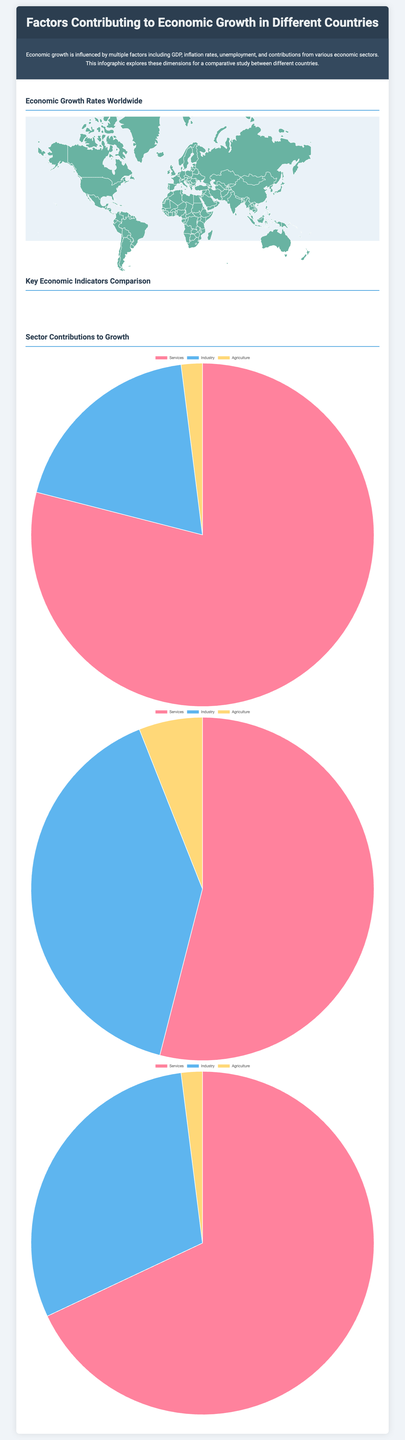what is the economic growth rate for China? The economic growth rate for China is depicted in the world map section, showing that it is 6.0.
Answer: 6.0 which country has the highest unemployment rate among those compared in the radar chart? The radar chart compares key economic indicators, indicating that the United States has the highest unemployment rate at 4.0.
Answer: 4.0 what percentage of the United States economy is contributed by the services sector? The pie chart for the United States illustrates that the services sector contributes 79.0% to the economy.
Answer: 79.0% which two countries have similar inflation rates according to the radar chart? The radar chart reveals that Germany and China both have similar inflation rates of 1.8 and 2.5, respectively.
Answer: Germany and China what is the total contribution of agriculture to Germany's economy? The pie chart for Germany highlights that agriculture contributes 2.0% to the economy.
Answer: 2.0% which region has the lowest growth rate among the countries depicted? The map indicates that South America has the lowest growth rates with Argentina at -2.0%.
Answer: South America how many countries are represented in the radar chart comparisons? The radar chart presents comparisons for three countries, which are the United States, Germany, and China.
Answer: three countries which sector contributes the least to China's economic growth based on the pie chart? The pie chart for China shows that agriculture, with a contribution of 6.0%, is the least contributing sector.
Answer: Agriculture what is the inflation rate for Germany as shown in the radar chart? According to the radar chart, Germany's inflation rate is 1.8.
Answer: 1.8 